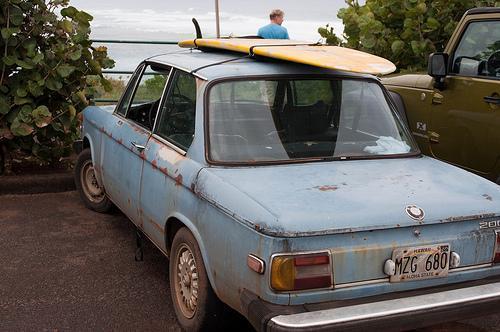How many vehicles are shown?
Give a very brief answer. 2. How many people are shown?
Give a very brief answer. 1. 